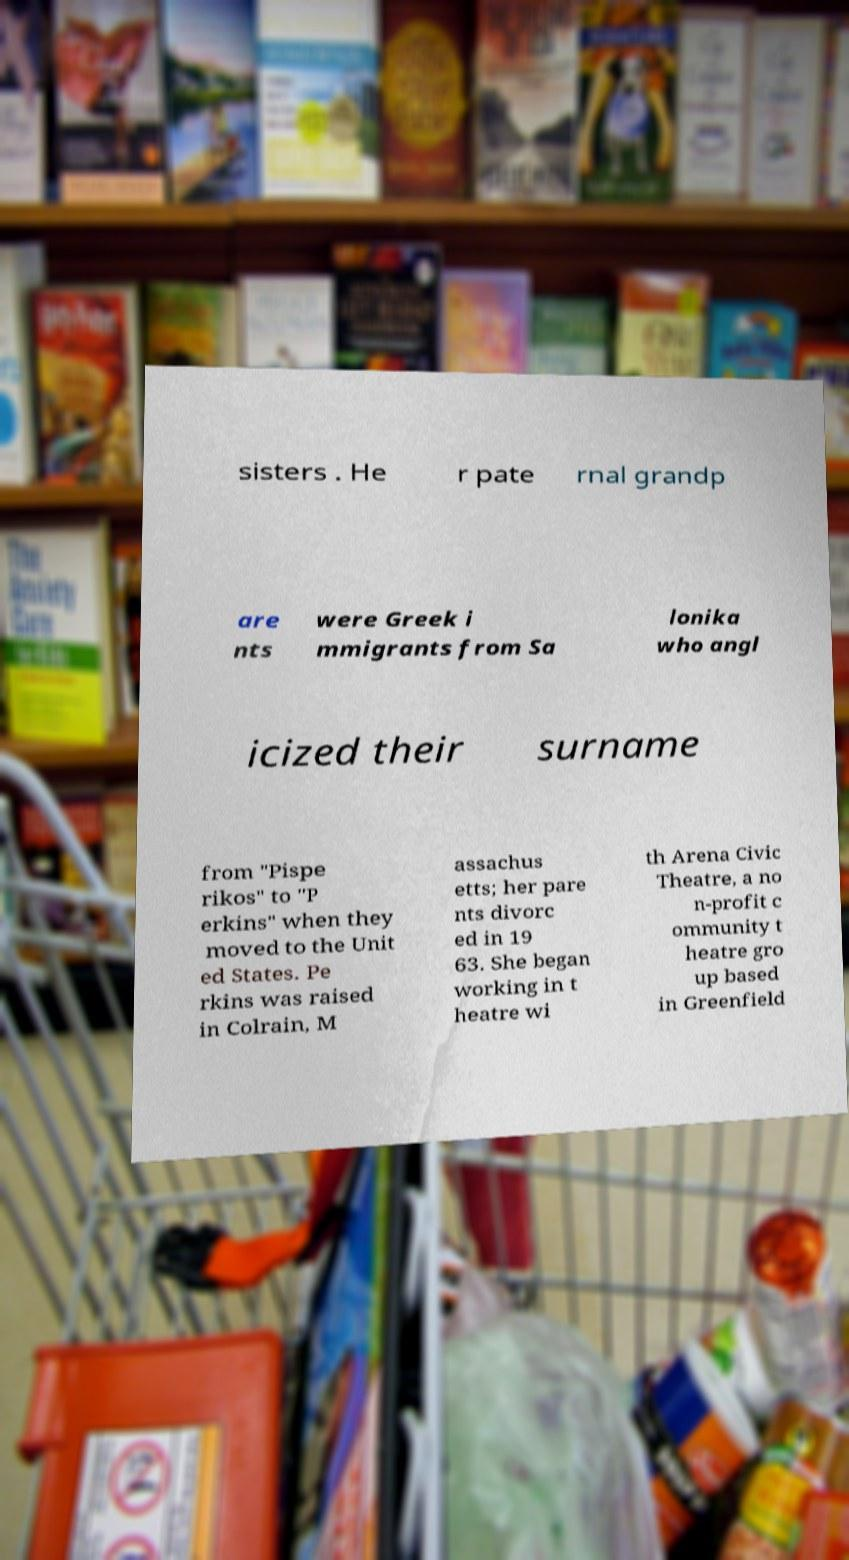Please identify and transcribe the text found in this image. sisters . He r pate rnal grandp are nts were Greek i mmigrants from Sa lonika who angl icized their surname from "Pispe rikos" to "P erkins" when they moved to the Unit ed States. Pe rkins was raised in Colrain, M assachus etts; her pare nts divorc ed in 19 63. She began working in t heatre wi th Arena Civic Theatre, a no n-profit c ommunity t heatre gro up based in Greenfield 